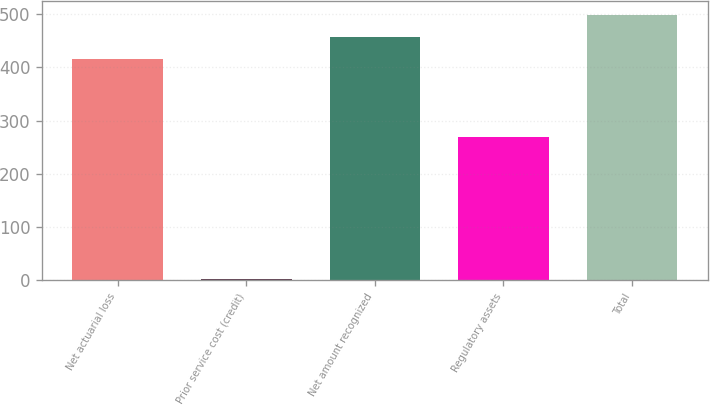Convert chart to OTSL. <chart><loc_0><loc_0><loc_500><loc_500><bar_chart><fcel>Net actuarial loss<fcel>Prior service cost (credit)<fcel>Net amount recognized<fcel>Regulatory assets<fcel>Total<nl><fcel>416<fcel>2<fcel>457.6<fcel>270<fcel>499.2<nl></chart> 